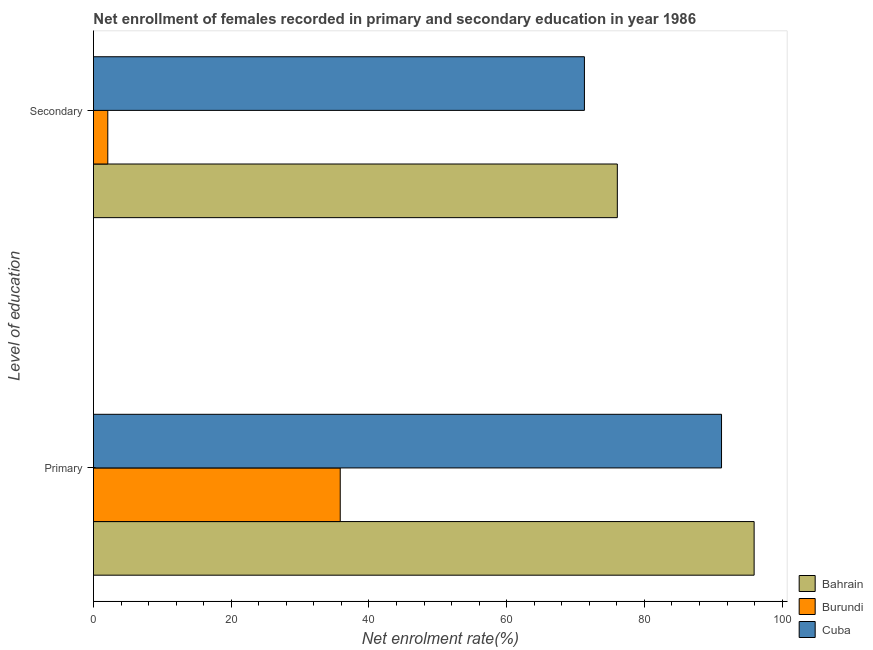How many groups of bars are there?
Your response must be concise. 2. Are the number of bars on each tick of the Y-axis equal?
Give a very brief answer. Yes. What is the label of the 1st group of bars from the top?
Your answer should be very brief. Secondary. What is the enrollment rate in primary education in Cuba?
Offer a terse response. 91.2. Across all countries, what is the maximum enrollment rate in secondary education?
Your response must be concise. 76.06. Across all countries, what is the minimum enrollment rate in secondary education?
Keep it short and to the point. 2.08. In which country was the enrollment rate in primary education maximum?
Ensure brevity in your answer.  Bahrain. In which country was the enrollment rate in secondary education minimum?
Your answer should be compact. Burundi. What is the total enrollment rate in primary education in the graph?
Your answer should be compact. 222.95. What is the difference between the enrollment rate in primary education in Bahrain and that in Cuba?
Your answer should be very brief. 4.73. What is the difference between the enrollment rate in primary education in Bahrain and the enrollment rate in secondary education in Cuba?
Offer a very short reply. 24.64. What is the average enrollment rate in secondary education per country?
Your answer should be compact. 49.81. What is the difference between the enrollment rate in secondary education and enrollment rate in primary education in Burundi?
Provide a succinct answer. -33.75. In how many countries, is the enrollment rate in primary education greater than 80 %?
Offer a very short reply. 2. What is the ratio of the enrollment rate in primary education in Cuba to that in Bahrain?
Offer a terse response. 0.95. Is the enrollment rate in primary education in Cuba less than that in Bahrain?
Your answer should be compact. Yes. In how many countries, is the enrollment rate in primary education greater than the average enrollment rate in primary education taken over all countries?
Your answer should be very brief. 2. What does the 2nd bar from the top in Primary represents?
Provide a succinct answer. Burundi. What does the 1st bar from the bottom in Secondary represents?
Your response must be concise. Bahrain. How many bars are there?
Offer a very short reply. 6. What is the difference between two consecutive major ticks on the X-axis?
Offer a terse response. 20. Are the values on the major ticks of X-axis written in scientific E-notation?
Provide a short and direct response. No. Where does the legend appear in the graph?
Your answer should be very brief. Bottom right. What is the title of the graph?
Provide a short and direct response. Net enrollment of females recorded in primary and secondary education in year 1986. What is the label or title of the X-axis?
Your answer should be very brief. Net enrolment rate(%). What is the label or title of the Y-axis?
Your answer should be compact. Level of education. What is the Net enrolment rate(%) of Bahrain in Primary?
Your answer should be compact. 95.93. What is the Net enrolment rate(%) of Burundi in Primary?
Provide a short and direct response. 35.83. What is the Net enrolment rate(%) in Cuba in Primary?
Offer a very short reply. 91.2. What is the Net enrolment rate(%) in Bahrain in Secondary?
Ensure brevity in your answer.  76.06. What is the Net enrolment rate(%) of Burundi in Secondary?
Give a very brief answer. 2.08. What is the Net enrolment rate(%) of Cuba in Secondary?
Your answer should be compact. 71.29. Across all Level of education, what is the maximum Net enrolment rate(%) in Bahrain?
Your response must be concise. 95.93. Across all Level of education, what is the maximum Net enrolment rate(%) in Burundi?
Offer a very short reply. 35.83. Across all Level of education, what is the maximum Net enrolment rate(%) in Cuba?
Your response must be concise. 91.2. Across all Level of education, what is the minimum Net enrolment rate(%) of Bahrain?
Make the answer very short. 76.06. Across all Level of education, what is the minimum Net enrolment rate(%) of Burundi?
Provide a succinct answer. 2.08. Across all Level of education, what is the minimum Net enrolment rate(%) of Cuba?
Give a very brief answer. 71.29. What is the total Net enrolment rate(%) in Bahrain in the graph?
Offer a terse response. 171.99. What is the total Net enrolment rate(%) in Burundi in the graph?
Your answer should be compact. 37.91. What is the total Net enrolment rate(%) in Cuba in the graph?
Give a very brief answer. 162.48. What is the difference between the Net enrolment rate(%) in Bahrain in Primary and that in Secondary?
Offer a very short reply. 19.86. What is the difference between the Net enrolment rate(%) in Burundi in Primary and that in Secondary?
Provide a short and direct response. 33.75. What is the difference between the Net enrolment rate(%) in Cuba in Primary and that in Secondary?
Offer a terse response. 19.91. What is the difference between the Net enrolment rate(%) of Bahrain in Primary and the Net enrolment rate(%) of Burundi in Secondary?
Ensure brevity in your answer.  93.85. What is the difference between the Net enrolment rate(%) in Bahrain in Primary and the Net enrolment rate(%) in Cuba in Secondary?
Your answer should be compact. 24.64. What is the difference between the Net enrolment rate(%) of Burundi in Primary and the Net enrolment rate(%) of Cuba in Secondary?
Your answer should be compact. -35.46. What is the average Net enrolment rate(%) in Bahrain per Level of education?
Keep it short and to the point. 86. What is the average Net enrolment rate(%) of Burundi per Level of education?
Provide a succinct answer. 18.96. What is the average Net enrolment rate(%) of Cuba per Level of education?
Your answer should be very brief. 81.24. What is the difference between the Net enrolment rate(%) in Bahrain and Net enrolment rate(%) in Burundi in Primary?
Give a very brief answer. 60.1. What is the difference between the Net enrolment rate(%) of Bahrain and Net enrolment rate(%) of Cuba in Primary?
Your answer should be very brief. 4.73. What is the difference between the Net enrolment rate(%) in Burundi and Net enrolment rate(%) in Cuba in Primary?
Ensure brevity in your answer.  -55.37. What is the difference between the Net enrolment rate(%) of Bahrain and Net enrolment rate(%) of Burundi in Secondary?
Your answer should be very brief. 73.98. What is the difference between the Net enrolment rate(%) in Bahrain and Net enrolment rate(%) in Cuba in Secondary?
Make the answer very short. 4.78. What is the difference between the Net enrolment rate(%) in Burundi and Net enrolment rate(%) in Cuba in Secondary?
Keep it short and to the point. -69.2. What is the ratio of the Net enrolment rate(%) in Bahrain in Primary to that in Secondary?
Give a very brief answer. 1.26. What is the ratio of the Net enrolment rate(%) in Burundi in Primary to that in Secondary?
Provide a succinct answer. 17.22. What is the ratio of the Net enrolment rate(%) in Cuba in Primary to that in Secondary?
Give a very brief answer. 1.28. What is the difference between the highest and the second highest Net enrolment rate(%) in Bahrain?
Provide a succinct answer. 19.86. What is the difference between the highest and the second highest Net enrolment rate(%) in Burundi?
Make the answer very short. 33.75. What is the difference between the highest and the second highest Net enrolment rate(%) in Cuba?
Offer a very short reply. 19.91. What is the difference between the highest and the lowest Net enrolment rate(%) in Bahrain?
Your answer should be very brief. 19.86. What is the difference between the highest and the lowest Net enrolment rate(%) of Burundi?
Your answer should be compact. 33.75. What is the difference between the highest and the lowest Net enrolment rate(%) of Cuba?
Provide a succinct answer. 19.91. 